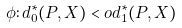<formula> <loc_0><loc_0><loc_500><loc_500>\phi \colon d _ { 0 } ^ { * } ( P , X ) < o d _ { 1 } ^ { * } ( P , X )</formula> 